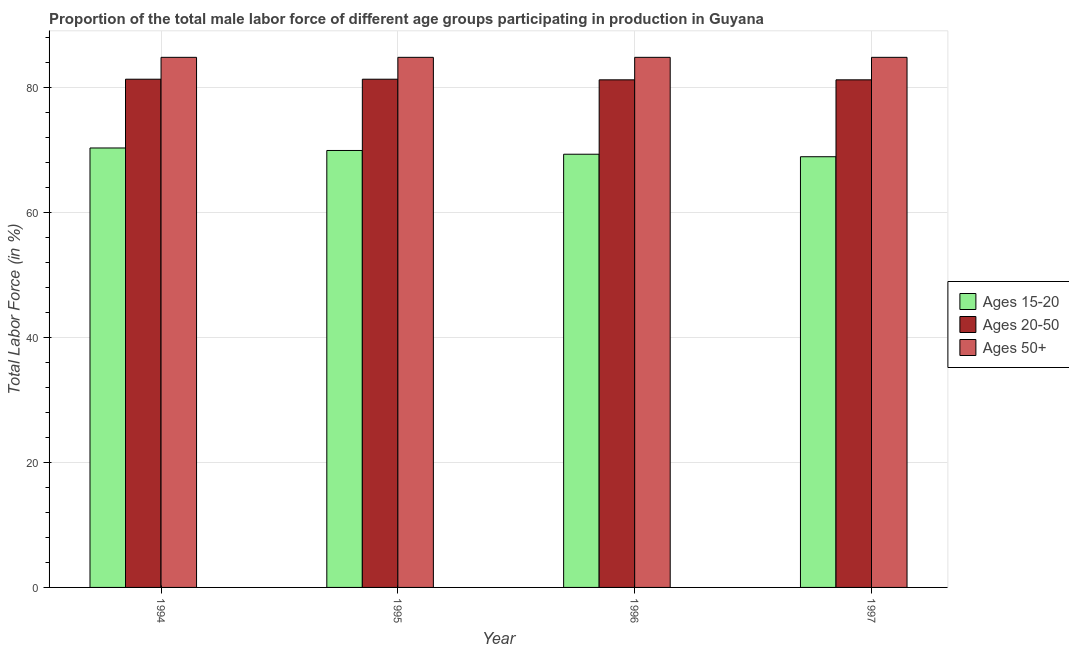How many groups of bars are there?
Provide a short and direct response. 4. Are the number of bars on each tick of the X-axis equal?
Ensure brevity in your answer.  Yes. How many bars are there on the 3rd tick from the left?
Offer a very short reply. 3. What is the percentage of male labor force within the age group 15-20 in 1995?
Give a very brief answer. 69.9. Across all years, what is the maximum percentage of male labor force above age 50?
Your response must be concise. 84.8. Across all years, what is the minimum percentage of male labor force above age 50?
Give a very brief answer. 84.8. In which year was the percentage of male labor force above age 50 minimum?
Offer a terse response. 1994. What is the total percentage of male labor force within the age group 15-20 in the graph?
Keep it short and to the point. 278.4. What is the difference between the percentage of male labor force within the age group 15-20 in 1994 and the percentage of male labor force above age 50 in 1995?
Your response must be concise. 0.4. What is the average percentage of male labor force within the age group 15-20 per year?
Ensure brevity in your answer.  69.6. In the year 1995, what is the difference between the percentage of male labor force within the age group 20-50 and percentage of male labor force within the age group 15-20?
Your answer should be very brief. 0. What is the ratio of the percentage of male labor force within the age group 15-20 in 1994 to that in 1997?
Provide a short and direct response. 1.02. What is the difference between the highest and the second highest percentage of male labor force above age 50?
Provide a succinct answer. 0. What is the difference between the highest and the lowest percentage of male labor force within the age group 15-20?
Offer a terse response. 1.4. In how many years, is the percentage of male labor force within the age group 20-50 greater than the average percentage of male labor force within the age group 20-50 taken over all years?
Provide a short and direct response. 2. What does the 3rd bar from the left in 1996 represents?
Give a very brief answer. Ages 50+. What does the 1st bar from the right in 1996 represents?
Your response must be concise. Ages 50+. Is it the case that in every year, the sum of the percentage of male labor force within the age group 15-20 and percentage of male labor force within the age group 20-50 is greater than the percentage of male labor force above age 50?
Keep it short and to the point. Yes. Are all the bars in the graph horizontal?
Give a very brief answer. No. What is the difference between two consecutive major ticks on the Y-axis?
Keep it short and to the point. 20. Does the graph contain any zero values?
Offer a very short reply. No. Does the graph contain grids?
Give a very brief answer. Yes. How are the legend labels stacked?
Your answer should be compact. Vertical. What is the title of the graph?
Offer a very short reply. Proportion of the total male labor force of different age groups participating in production in Guyana. Does "Ireland" appear as one of the legend labels in the graph?
Offer a terse response. No. What is the Total Labor Force (in %) in Ages 15-20 in 1994?
Provide a succinct answer. 70.3. What is the Total Labor Force (in %) of Ages 20-50 in 1994?
Ensure brevity in your answer.  81.3. What is the Total Labor Force (in %) of Ages 50+ in 1994?
Make the answer very short. 84.8. What is the Total Labor Force (in %) of Ages 15-20 in 1995?
Give a very brief answer. 69.9. What is the Total Labor Force (in %) in Ages 20-50 in 1995?
Ensure brevity in your answer.  81.3. What is the Total Labor Force (in %) in Ages 50+ in 1995?
Provide a succinct answer. 84.8. What is the Total Labor Force (in %) of Ages 15-20 in 1996?
Keep it short and to the point. 69.3. What is the Total Labor Force (in %) of Ages 20-50 in 1996?
Ensure brevity in your answer.  81.2. What is the Total Labor Force (in %) in Ages 50+ in 1996?
Keep it short and to the point. 84.8. What is the Total Labor Force (in %) of Ages 15-20 in 1997?
Your response must be concise. 68.9. What is the Total Labor Force (in %) in Ages 20-50 in 1997?
Make the answer very short. 81.2. What is the Total Labor Force (in %) of Ages 50+ in 1997?
Your answer should be very brief. 84.8. Across all years, what is the maximum Total Labor Force (in %) in Ages 15-20?
Keep it short and to the point. 70.3. Across all years, what is the maximum Total Labor Force (in %) in Ages 20-50?
Offer a terse response. 81.3. Across all years, what is the maximum Total Labor Force (in %) in Ages 50+?
Provide a short and direct response. 84.8. Across all years, what is the minimum Total Labor Force (in %) of Ages 15-20?
Provide a succinct answer. 68.9. Across all years, what is the minimum Total Labor Force (in %) of Ages 20-50?
Provide a succinct answer. 81.2. Across all years, what is the minimum Total Labor Force (in %) in Ages 50+?
Give a very brief answer. 84.8. What is the total Total Labor Force (in %) of Ages 15-20 in the graph?
Make the answer very short. 278.4. What is the total Total Labor Force (in %) of Ages 20-50 in the graph?
Provide a succinct answer. 325. What is the total Total Labor Force (in %) in Ages 50+ in the graph?
Ensure brevity in your answer.  339.2. What is the difference between the Total Labor Force (in %) in Ages 50+ in 1994 and that in 1995?
Offer a terse response. 0. What is the difference between the Total Labor Force (in %) of Ages 20-50 in 1994 and that in 1996?
Offer a very short reply. 0.1. What is the difference between the Total Labor Force (in %) of Ages 15-20 in 1994 and that in 1997?
Your answer should be compact. 1.4. What is the difference between the Total Labor Force (in %) in Ages 50+ in 1994 and that in 1997?
Your answer should be compact. 0. What is the difference between the Total Labor Force (in %) in Ages 15-20 in 1995 and that in 1996?
Provide a short and direct response. 0.6. What is the difference between the Total Labor Force (in %) in Ages 20-50 in 1995 and that in 1996?
Your response must be concise. 0.1. What is the difference between the Total Labor Force (in %) in Ages 50+ in 1995 and that in 1996?
Ensure brevity in your answer.  0. What is the difference between the Total Labor Force (in %) of Ages 15-20 in 1995 and that in 1997?
Your answer should be compact. 1. What is the difference between the Total Labor Force (in %) in Ages 50+ in 1995 and that in 1997?
Provide a succinct answer. 0. What is the difference between the Total Labor Force (in %) of Ages 50+ in 1996 and that in 1997?
Provide a succinct answer. 0. What is the difference between the Total Labor Force (in %) of Ages 15-20 in 1994 and the Total Labor Force (in %) of Ages 50+ in 1996?
Offer a terse response. -14.5. What is the difference between the Total Labor Force (in %) of Ages 20-50 in 1994 and the Total Labor Force (in %) of Ages 50+ in 1996?
Keep it short and to the point. -3.5. What is the difference between the Total Labor Force (in %) of Ages 15-20 in 1994 and the Total Labor Force (in %) of Ages 20-50 in 1997?
Offer a very short reply. -10.9. What is the difference between the Total Labor Force (in %) of Ages 15-20 in 1994 and the Total Labor Force (in %) of Ages 50+ in 1997?
Your answer should be compact. -14.5. What is the difference between the Total Labor Force (in %) of Ages 20-50 in 1994 and the Total Labor Force (in %) of Ages 50+ in 1997?
Keep it short and to the point. -3.5. What is the difference between the Total Labor Force (in %) in Ages 15-20 in 1995 and the Total Labor Force (in %) in Ages 20-50 in 1996?
Your answer should be very brief. -11.3. What is the difference between the Total Labor Force (in %) of Ages 15-20 in 1995 and the Total Labor Force (in %) of Ages 50+ in 1996?
Provide a short and direct response. -14.9. What is the difference between the Total Labor Force (in %) in Ages 20-50 in 1995 and the Total Labor Force (in %) in Ages 50+ in 1996?
Your answer should be compact. -3.5. What is the difference between the Total Labor Force (in %) of Ages 15-20 in 1995 and the Total Labor Force (in %) of Ages 20-50 in 1997?
Provide a short and direct response. -11.3. What is the difference between the Total Labor Force (in %) of Ages 15-20 in 1995 and the Total Labor Force (in %) of Ages 50+ in 1997?
Your answer should be very brief. -14.9. What is the difference between the Total Labor Force (in %) of Ages 15-20 in 1996 and the Total Labor Force (in %) of Ages 20-50 in 1997?
Ensure brevity in your answer.  -11.9. What is the difference between the Total Labor Force (in %) in Ages 15-20 in 1996 and the Total Labor Force (in %) in Ages 50+ in 1997?
Keep it short and to the point. -15.5. What is the difference between the Total Labor Force (in %) of Ages 20-50 in 1996 and the Total Labor Force (in %) of Ages 50+ in 1997?
Make the answer very short. -3.6. What is the average Total Labor Force (in %) of Ages 15-20 per year?
Offer a terse response. 69.6. What is the average Total Labor Force (in %) in Ages 20-50 per year?
Offer a very short reply. 81.25. What is the average Total Labor Force (in %) in Ages 50+ per year?
Your answer should be compact. 84.8. In the year 1994, what is the difference between the Total Labor Force (in %) in Ages 15-20 and Total Labor Force (in %) in Ages 20-50?
Your answer should be compact. -11. In the year 1994, what is the difference between the Total Labor Force (in %) in Ages 15-20 and Total Labor Force (in %) in Ages 50+?
Give a very brief answer. -14.5. In the year 1994, what is the difference between the Total Labor Force (in %) of Ages 20-50 and Total Labor Force (in %) of Ages 50+?
Provide a succinct answer. -3.5. In the year 1995, what is the difference between the Total Labor Force (in %) in Ages 15-20 and Total Labor Force (in %) in Ages 20-50?
Your answer should be very brief. -11.4. In the year 1995, what is the difference between the Total Labor Force (in %) in Ages 15-20 and Total Labor Force (in %) in Ages 50+?
Provide a succinct answer. -14.9. In the year 1996, what is the difference between the Total Labor Force (in %) of Ages 15-20 and Total Labor Force (in %) of Ages 50+?
Provide a succinct answer. -15.5. In the year 1997, what is the difference between the Total Labor Force (in %) of Ages 15-20 and Total Labor Force (in %) of Ages 20-50?
Offer a very short reply. -12.3. In the year 1997, what is the difference between the Total Labor Force (in %) in Ages 15-20 and Total Labor Force (in %) in Ages 50+?
Keep it short and to the point. -15.9. What is the ratio of the Total Labor Force (in %) in Ages 50+ in 1994 to that in 1995?
Provide a short and direct response. 1. What is the ratio of the Total Labor Force (in %) in Ages 15-20 in 1994 to that in 1996?
Provide a succinct answer. 1.01. What is the ratio of the Total Labor Force (in %) of Ages 20-50 in 1994 to that in 1996?
Your response must be concise. 1. What is the ratio of the Total Labor Force (in %) of Ages 15-20 in 1994 to that in 1997?
Your response must be concise. 1.02. What is the ratio of the Total Labor Force (in %) of Ages 20-50 in 1994 to that in 1997?
Give a very brief answer. 1. What is the ratio of the Total Labor Force (in %) in Ages 15-20 in 1995 to that in 1996?
Provide a short and direct response. 1.01. What is the ratio of the Total Labor Force (in %) in Ages 15-20 in 1995 to that in 1997?
Offer a very short reply. 1.01. What is the ratio of the Total Labor Force (in %) in Ages 20-50 in 1995 to that in 1997?
Keep it short and to the point. 1. What is the ratio of the Total Labor Force (in %) in Ages 50+ in 1996 to that in 1997?
Offer a very short reply. 1. What is the difference between the highest and the lowest Total Labor Force (in %) of Ages 20-50?
Your answer should be very brief. 0.1. What is the difference between the highest and the lowest Total Labor Force (in %) in Ages 50+?
Ensure brevity in your answer.  0. 